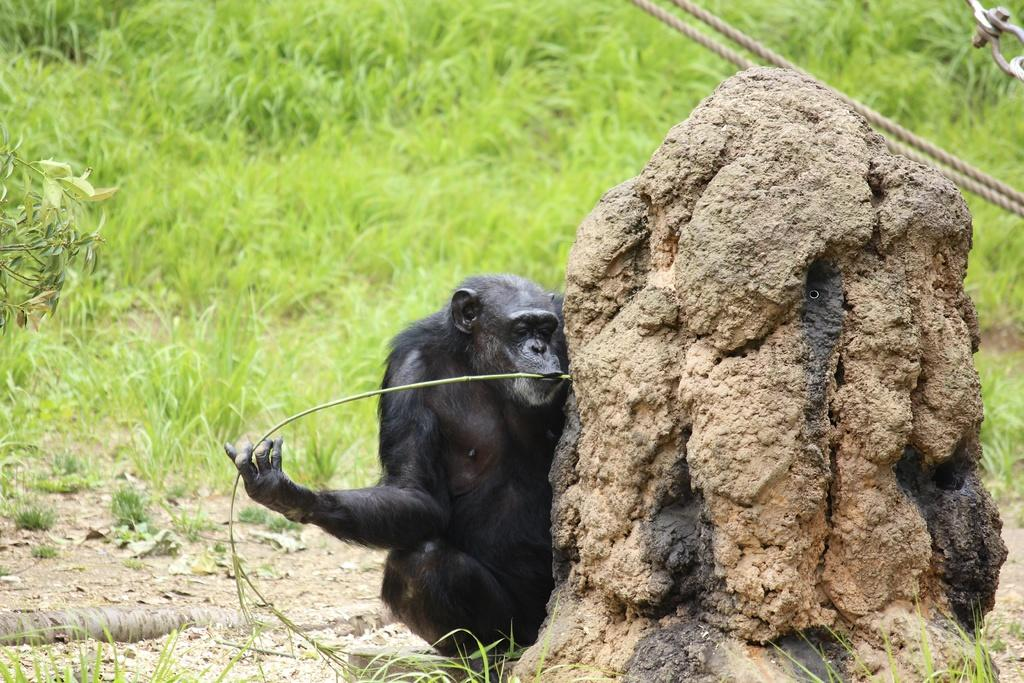What animal is in the foreground of the image? There is a chimpanzee in the foreground of the image. What is the chimpanzee holding in its hands? The chimpanzee is holding a stem and a stone. What can be seen in the background of the image? There are ropes and grassland in the background of the image. What type of honey can be seen in the image? There is no honey present in the image. 